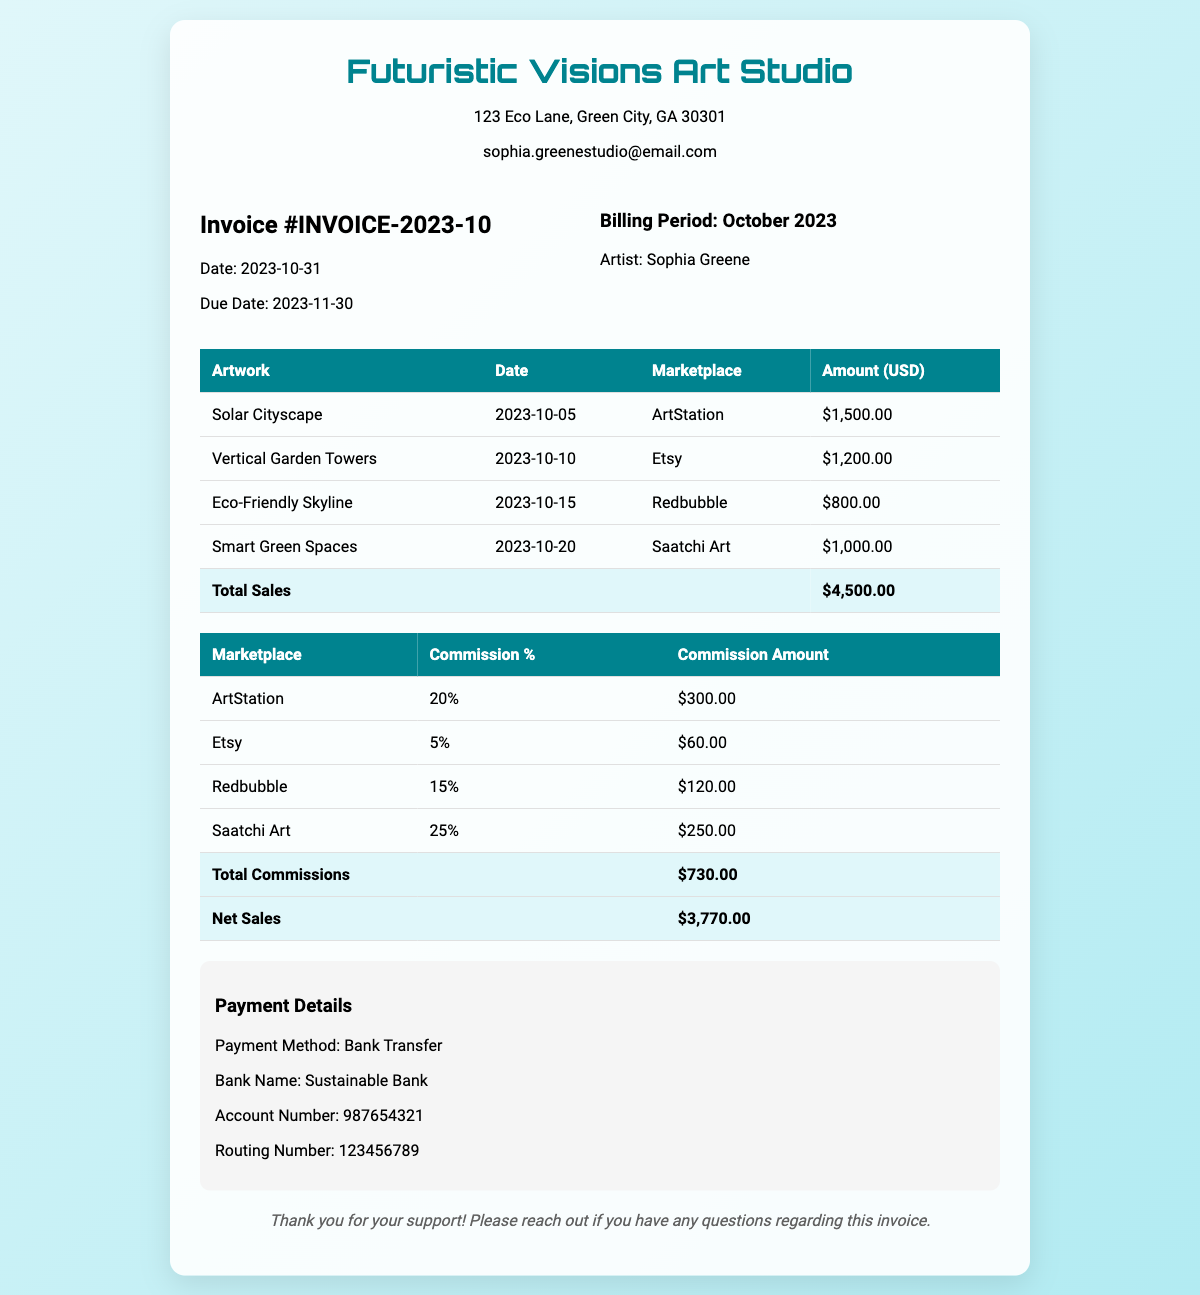what is the invoice number? The invoice number is listed at the top of the document as Invoice #INVOICE-2023-10.
Answer: Invoice #INVOICE-2023-10 what is the total sales amount? The total sales amount is shown in the total row at the bottom of the sales table, which is $4,500.00.
Answer: $4,500.00 who is the artist? The artist's name is mentioned in the billing period section, which identifies the artist as Sophia Greene.
Answer: Sophia Greene what is the commission amount for Etsy? The commission amount for Etsy is included in the commission table, which specifically states it as $60.00.
Answer: $60.00 what is the net sales amount? The net sales amount can be found in the total row of the commission table, which indicates it as $3,770.00.
Answer: $3,770.00 how many artworks are listed in the sales breakdown? The sales breakdown lists multiple artworks, specifically counting the rows in the artwork sales table, total artworks listed are 4.
Answer: 4 what is the due date for the invoice? The due date is provided in the subheader section of the document, specifically stated as November 30, 2023.
Answer: 2023-11-30 which marketplace had the highest commission rate? The highest commission rate can be found in the commission table, where Saatchi Art is listed with a 25% rate.
Answer: Saatchi Art what payment method is indicated in the payment details? The payment method is specified in the payment information section, which states it is a Bank Transfer.
Answer: Bank Transfer 